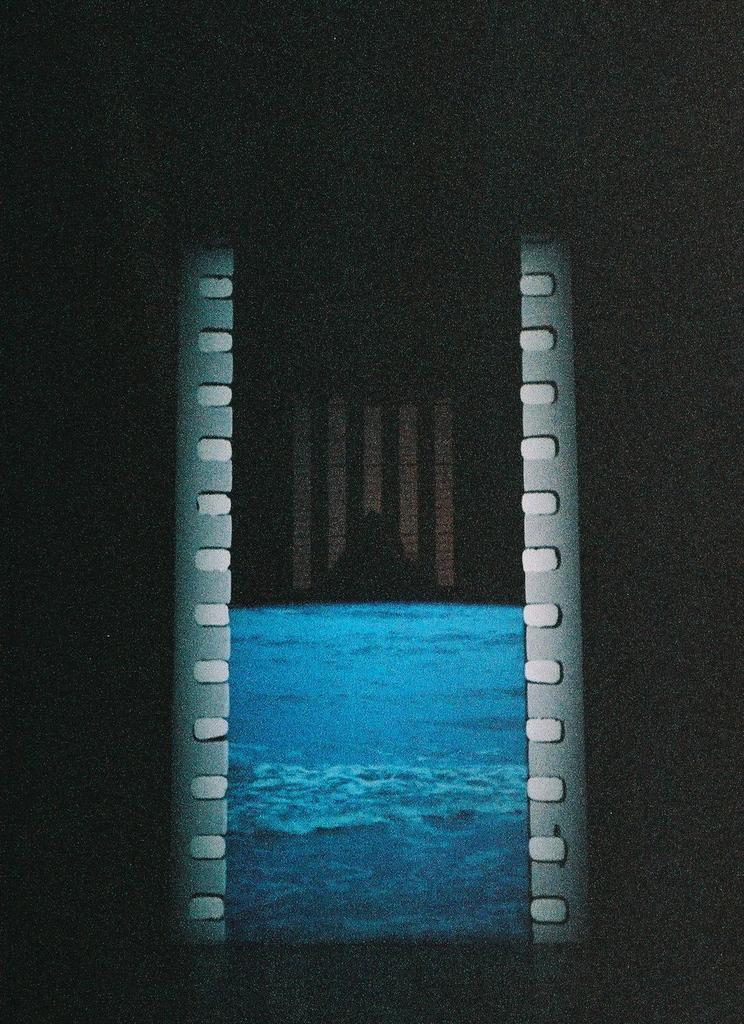Describe this image in one or two sentences. This is a blurry image. In this image, we can see the water. The background of the image is dark. 